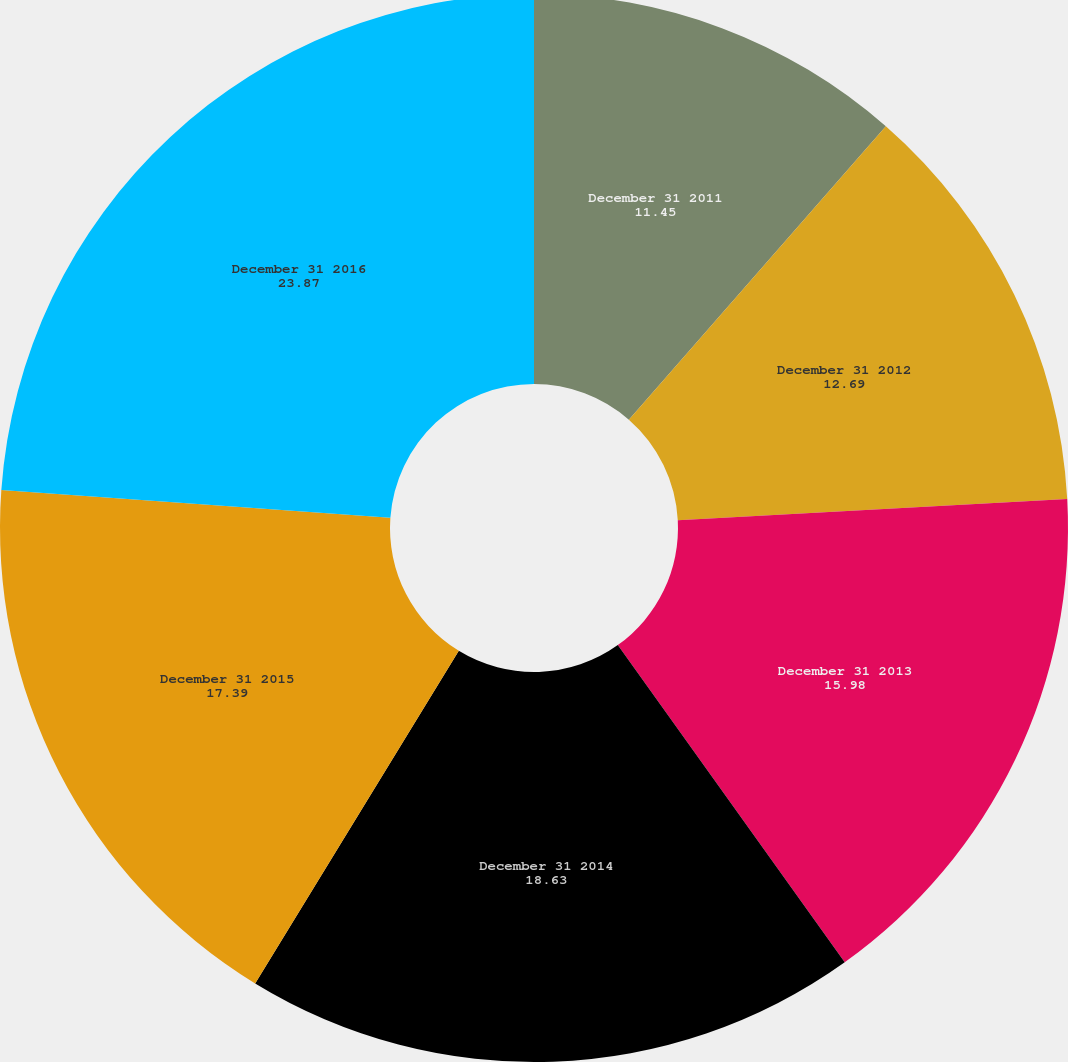<chart> <loc_0><loc_0><loc_500><loc_500><pie_chart><fcel>December 31 2011<fcel>December 31 2012<fcel>December 31 2013<fcel>December 31 2014<fcel>December 31 2015<fcel>December 31 2016<nl><fcel>11.45%<fcel>12.69%<fcel>15.98%<fcel>18.63%<fcel>17.39%<fcel>23.87%<nl></chart> 